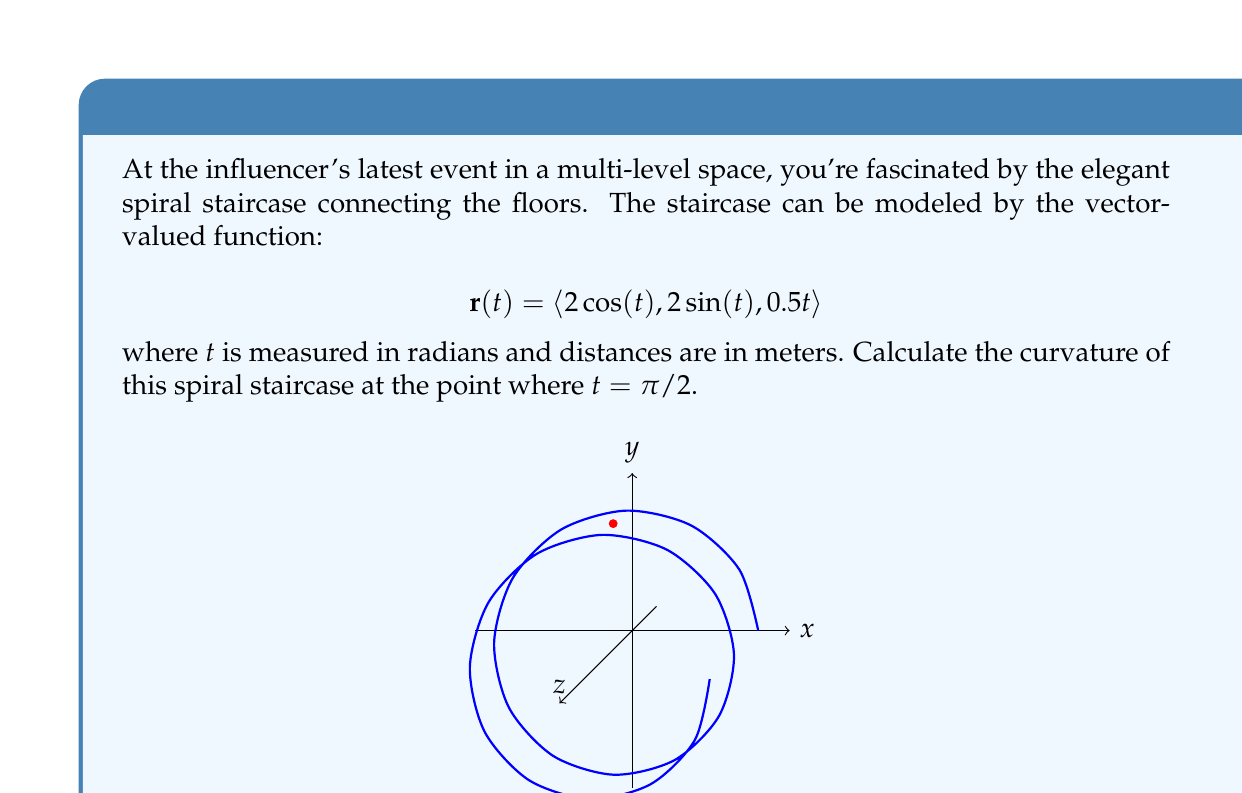Provide a solution to this math problem. Let's approach this step-by-step:

1) The curvature $\kappa$ of a vector-valued function is given by:

   $$\kappa = \frac{|\mathbf{r}'(t) \times \mathbf{r}''(t)|}{|\mathbf{r}'(t)|^3}$$

2) First, let's find $\mathbf{r}'(t)$:
   $$\mathbf{r}'(t) = \langle -2\sin(t), 2\cos(t), 0.5 \rangle$$

3) Now, let's find $\mathbf{r}''(t)$:
   $$\mathbf{r}''(t) = \langle -2\cos(t), -2\sin(t), 0 \rangle$$

4) We need to evaluate these at $t = \pi/2$:
   $$\mathbf{r}'(\pi/2) = \langle -2, 0, 0.5 \rangle$$
   $$\mathbf{r}''(\pi/2) = \langle 0, -2, 0 \rangle$$

5) Now, let's calculate the cross product $\mathbf{r}'(\pi/2) \times \mathbf{r}''(\pi/2)$:
   $$\mathbf{r}'(\pi/2) \times \mathbf{r}''(\pi/2) = \langle -1, 0, -4 \rangle$$

6) The magnitude of this cross product is:
   $$|\mathbf{r}'(\pi/2) \times \mathbf{r}''(\pi/2)| = \sqrt{(-1)^2 + 0^2 + (-4)^2} = \sqrt{17}$$

7) Next, we need $|\mathbf{r}'(\pi/2)|^3$:
   $$|\mathbf{r}'(\pi/2)| = \sqrt{(-2)^2 + 0^2 + (0.5)^2} = \sqrt{4.25}$$
   $$|\mathbf{r}'(\pi/2)|^3 = (\sqrt{4.25})^3 = 4.25\sqrt{4.25}$$

8) Finally, we can calculate the curvature:
   $$\kappa = \frac{\sqrt{17}}{4.25\sqrt{4.25}} = \frac{\sqrt{17}}{8.75}$$
Answer: $\frac{\sqrt{17}}{8.75}$ m$^{-1}$ 